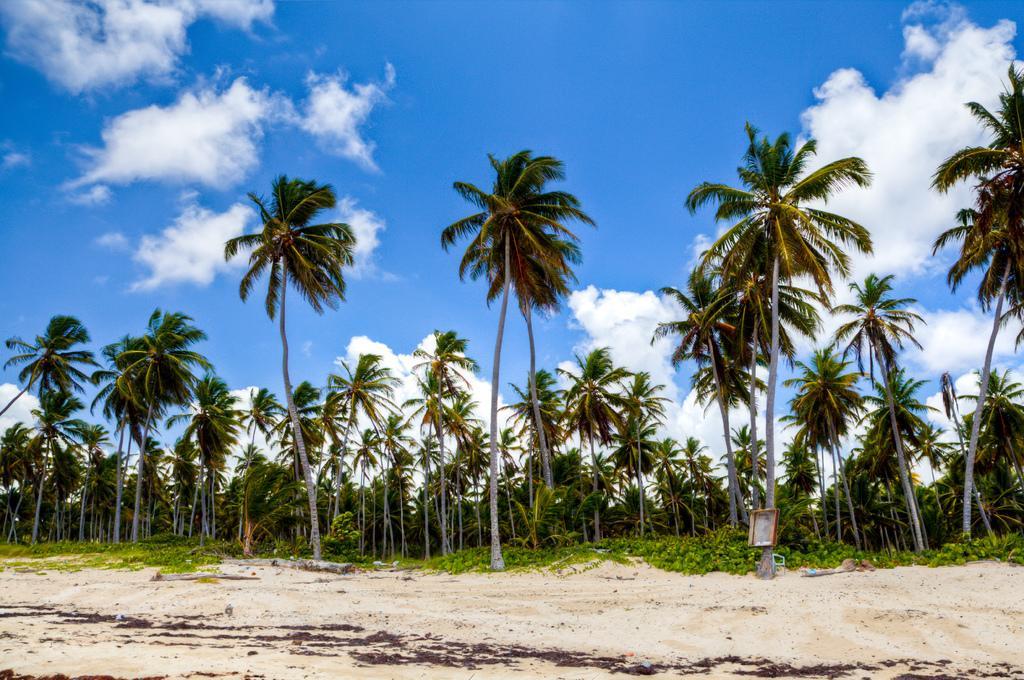Could you give a brief overview of what you see in this image? In this image I can see trees in the center of the image. Sand at the bottom of the image and sky at the top of the image. 